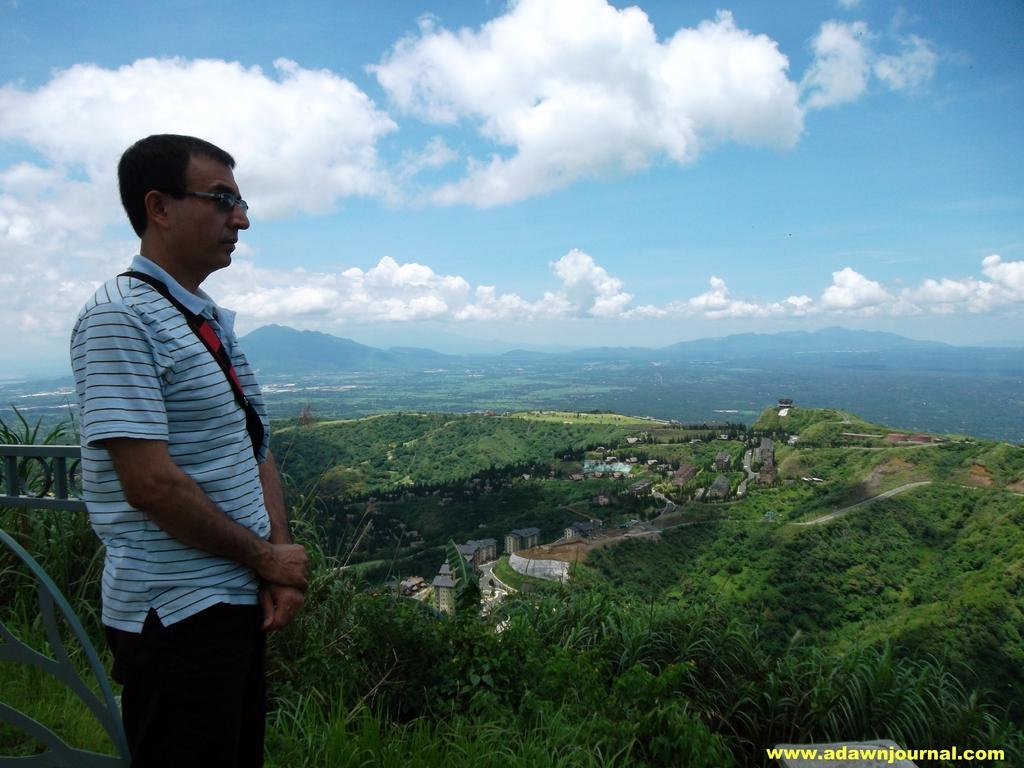What can be seen in the image? There is a person standing in the image, and they are wearing glasses (specs). What is visible in the background of the image? There are many trees, houses, and mountains visible in the background of the image. What is the condition of the sky in the image? The sky is visible in the image, and there are clouds present. Can you tell me how many icicles are hanging from the person's glasses in the image? There are no icicles present in the image, as it is not a cold environment where icicles would form. What type of army is depicted in the image? There is no army present in the image; it features a person standing and wearing glasses, along with the background elements. 